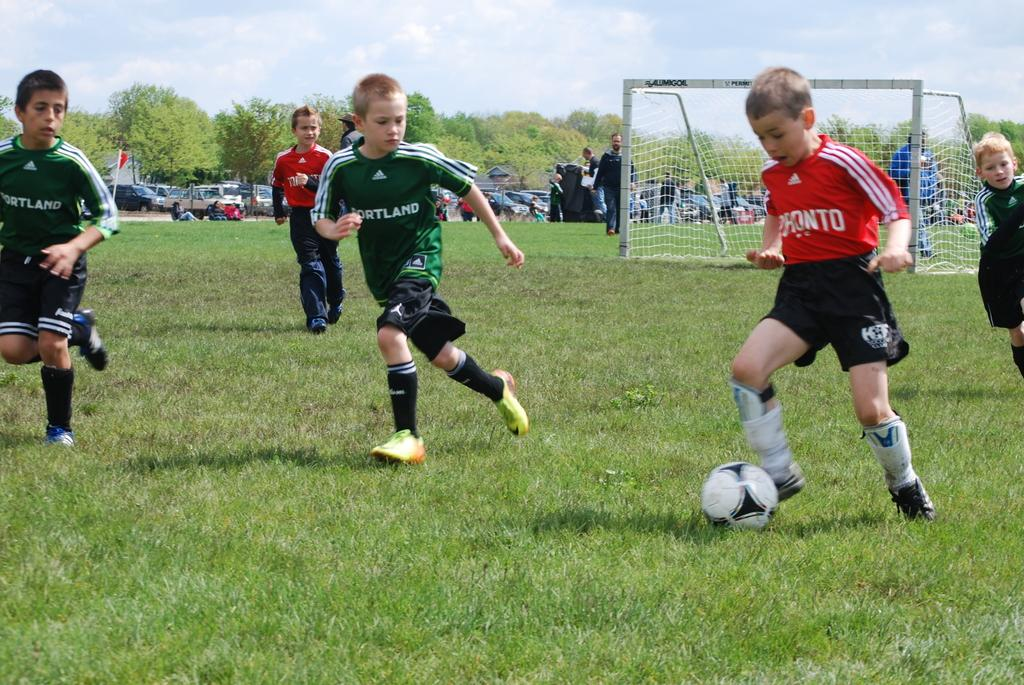<image>
Present a compact description of the photo's key features. A box on team Portland chases an opposing teams player as he kicks the soccer ball down the field. 